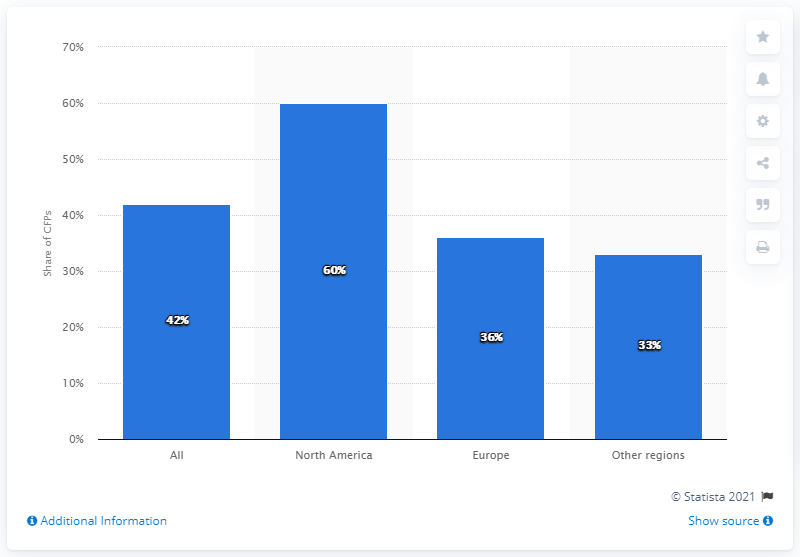Specify some key components in this picture. In 2011, approximately 60% of CFPs in North America charged a transaction fee based on a percentage commission of the funds paid out. 